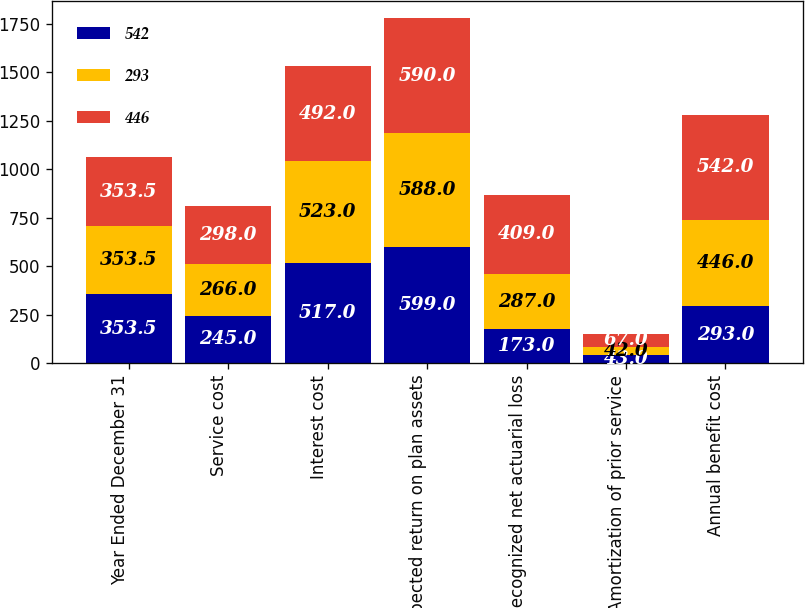Convert chart. <chart><loc_0><loc_0><loc_500><loc_500><stacked_bar_chart><ecel><fcel>Year Ended December 31<fcel>Service cost<fcel>Interest cost<fcel>Expected return on plan assets<fcel>Recognized net actuarial loss<fcel>Amortization of prior service<fcel>Annual benefit cost<nl><fcel>542<fcel>353.5<fcel>245<fcel>517<fcel>599<fcel>173<fcel>43<fcel>293<nl><fcel>293<fcel>353.5<fcel>266<fcel>523<fcel>588<fcel>287<fcel>42<fcel>446<nl><fcel>446<fcel>353.5<fcel>298<fcel>492<fcel>590<fcel>409<fcel>67<fcel>542<nl></chart> 